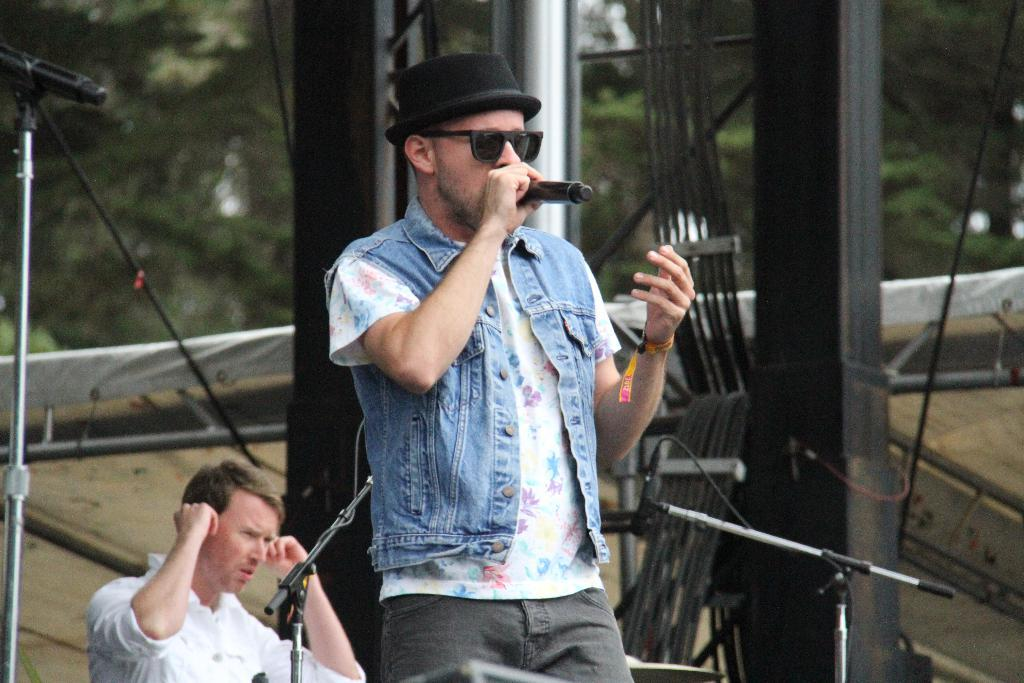What is the man in the image doing? The man is standing in the image and holding a mic in one of his hands. What is the purpose of the mic in the image? The mic is likely being used for speaking or singing, as the man is holding it. Can you describe the background of the image? In the background, there is a mic stand, a cable attached to it, grills, and trees. What type of vegetation can be seen in the background? Trees are visible in the background. What type of mask is the man wearing in the image? There is no mask visible on the man in the image. What color is the paint on the grills in the background? There is no mention of paint or color on the grills in the image; they are simply described as grills. 